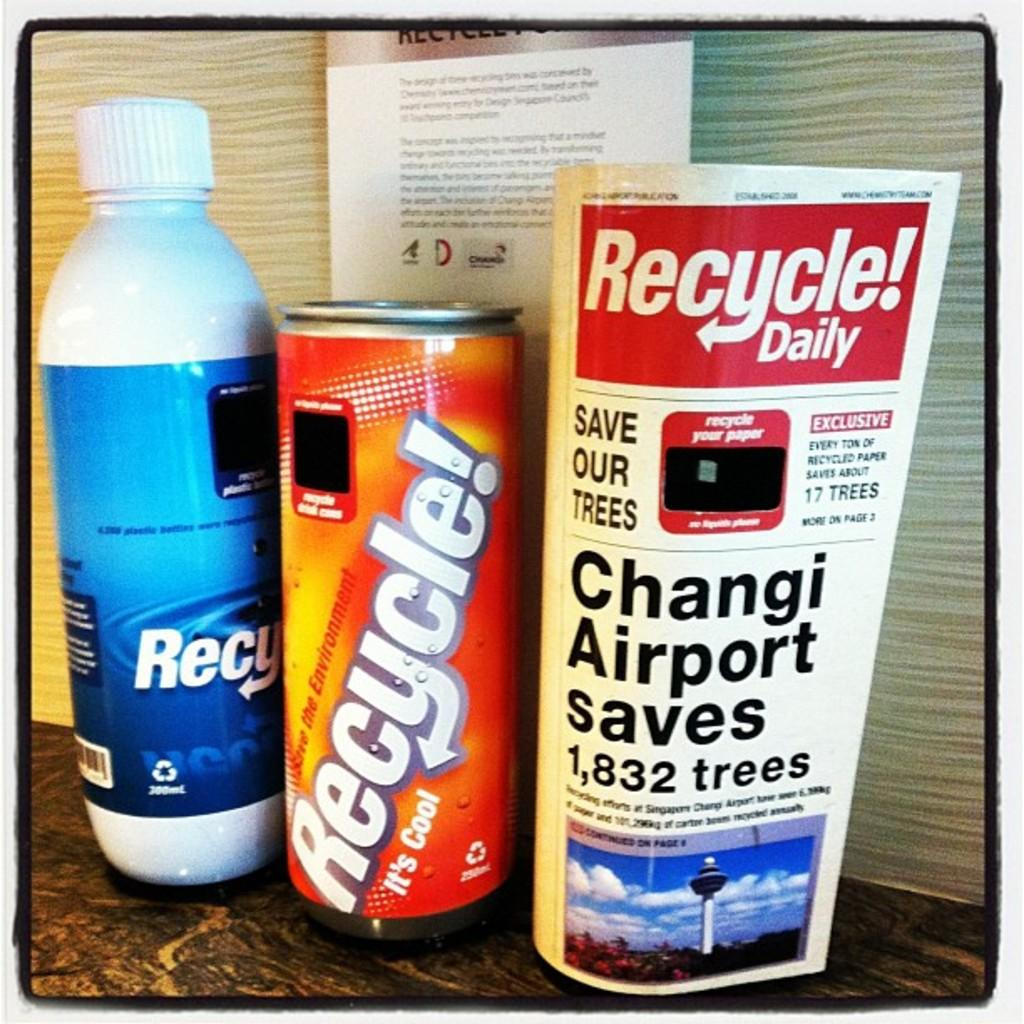<image>
Provide a brief description of the given image. a can that has the word recycle on it 